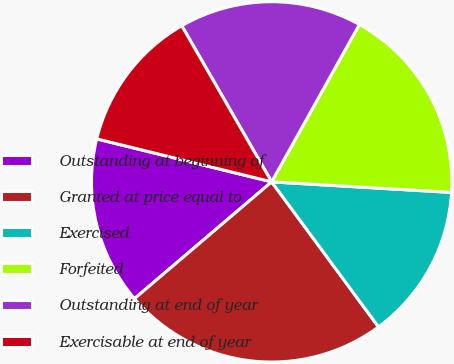Convert chart to OTSL. <chart><loc_0><loc_0><loc_500><loc_500><pie_chart><fcel>Outstanding at beginning of<fcel>Granted at price equal to<fcel>Exercised<fcel>Forfeited<fcel>Outstanding at end of year<fcel>Exercisable at end of year<nl><fcel>15.06%<fcel>23.88%<fcel>13.96%<fcel>17.84%<fcel>16.41%<fcel>12.85%<nl></chart> 